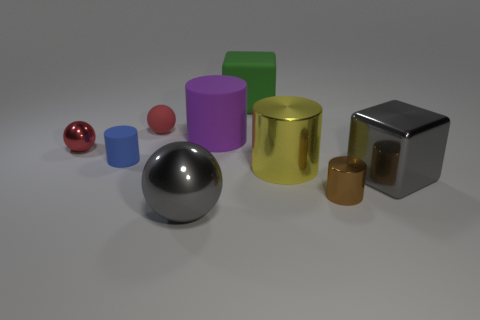Subtract all big metal balls. How many balls are left? 2 Add 1 big purple matte things. How many objects exist? 10 Subtract all red balls. How many balls are left? 1 Subtract 3 balls. How many balls are left? 0 Subtract all yellow cylinders. How many red spheres are left? 2 Subtract 0 blue balls. How many objects are left? 9 Subtract all cylinders. How many objects are left? 5 Subtract all green balls. Subtract all blue cylinders. How many balls are left? 3 Subtract all large blue things. Subtract all gray things. How many objects are left? 7 Add 2 blue things. How many blue things are left? 3 